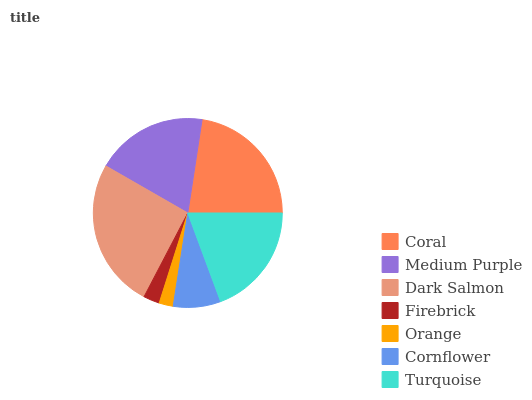Is Orange the minimum?
Answer yes or no. Yes. Is Dark Salmon the maximum?
Answer yes or no. Yes. Is Medium Purple the minimum?
Answer yes or no. No. Is Medium Purple the maximum?
Answer yes or no. No. Is Coral greater than Medium Purple?
Answer yes or no. Yes. Is Medium Purple less than Coral?
Answer yes or no. Yes. Is Medium Purple greater than Coral?
Answer yes or no. No. Is Coral less than Medium Purple?
Answer yes or no. No. Is Medium Purple the high median?
Answer yes or no. Yes. Is Medium Purple the low median?
Answer yes or no. Yes. Is Turquoise the high median?
Answer yes or no. No. Is Turquoise the low median?
Answer yes or no. No. 